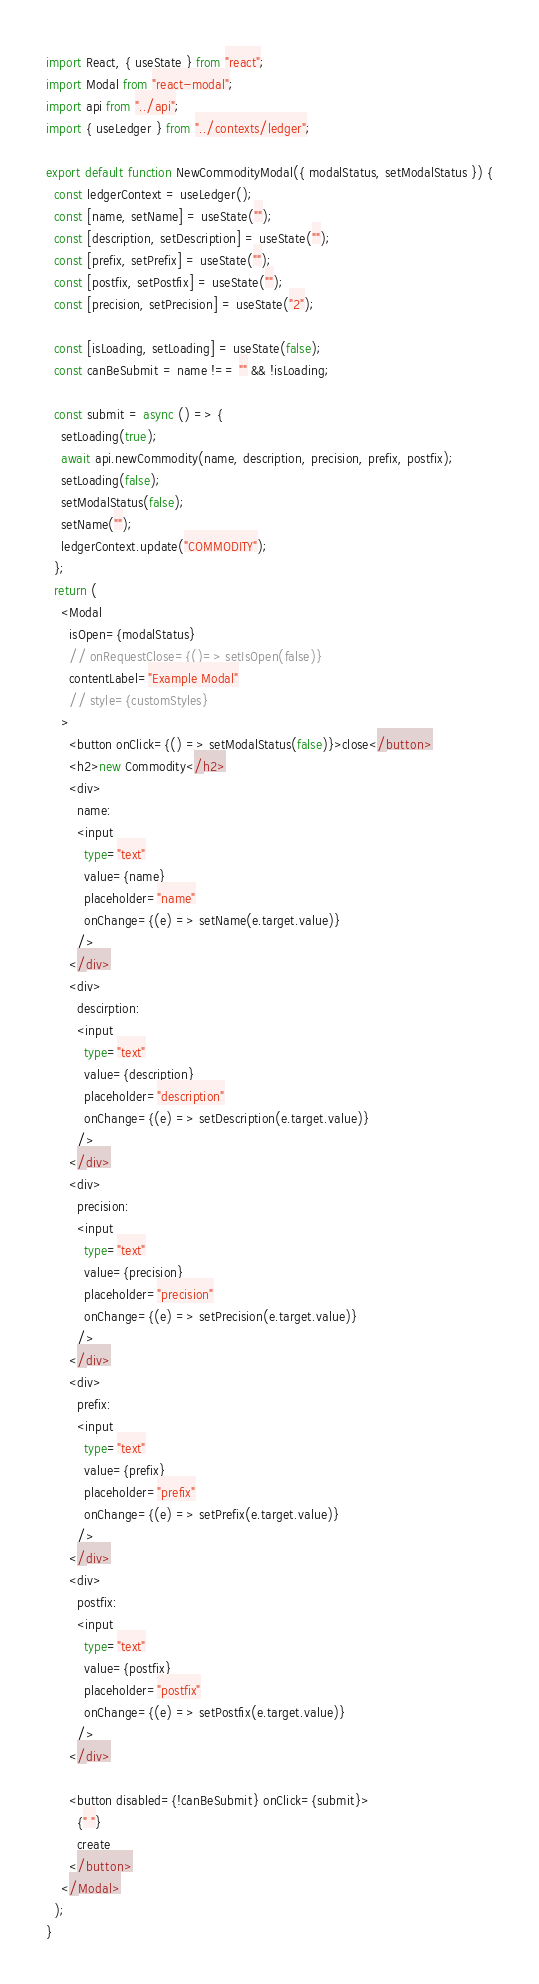<code> <loc_0><loc_0><loc_500><loc_500><_TypeScript_>import React, { useState } from "react";
import Modal from "react-modal";
import api from "../api";
import { useLedger } from "../contexts/ledger";

export default function NewCommodityModal({ modalStatus, setModalStatus }) {
  const ledgerContext = useLedger();
  const [name, setName] = useState("");
  const [description, setDescription] = useState("");
  const [prefix, setPrefix] = useState("");
  const [postfix, setPostfix] = useState("");
  const [precision, setPrecision] = useState("2");

  const [isLoading, setLoading] = useState(false);
  const canBeSubmit = name !== "" && !isLoading;

  const submit = async () => {
    setLoading(true);
    await api.newCommodity(name, description, precision, prefix, postfix);
    setLoading(false);
    setModalStatus(false);
    setName("");
    ledgerContext.update("COMMODITY");
  };
  return (
    <Modal
      isOpen={modalStatus}
      // onRequestClose={()=> setIsOpen(false)}
      contentLabel="Example Modal"
      // style={customStyles}
    >
      <button onClick={() => setModalStatus(false)}>close</button>
      <h2>new Commodity</h2>
      <div>
        name:
        <input
          type="text"
          value={name}
          placeholder="name"
          onChange={(e) => setName(e.target.value)}
        />
      </div>
      <div>
        descirption:
        <input
          type="text"
          value={description}
          placeholder="description"
          onChange={(e) => setDescription(e.target.value)}
        />
      </div>
      <div>
        precision:
        <input
          type="text"
          value={precision}
          placeholder="precision"
          onChange={(e) => setPrecision(e.target.value)}
        />
      </div>
      <div>
        prefix:
        <input
          type="text"
          value={prefix}
          placeholder="prefix"
          onChange={(e) => setPrefix(e.target.value)}
        />
      </div>
      <div>
        postfix:
        <input
          type="text"
          value={postfix}
          placeholder="postfix"
          onChange={(e) => setPostfix(e.target.value)}
        />
      </div>

      <button disabled={!canBeSubmit} onClick={submit}>
        {" "}
        create
      </button>
    </Modal>
  );
}
</code> 